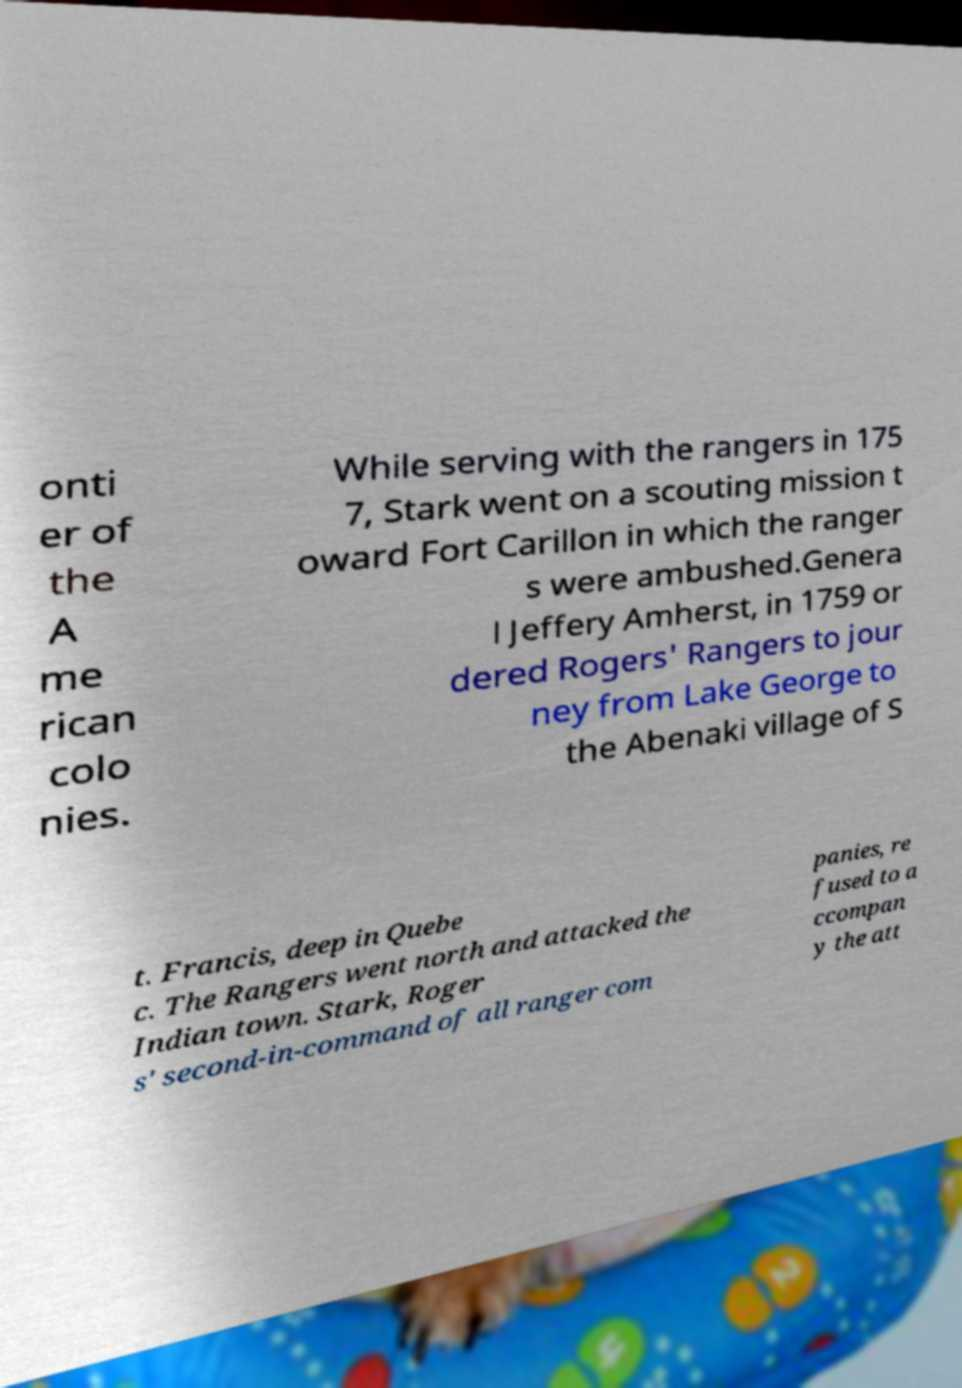Please identify and transcribe the text found in this image. onti er of the A me rican colo nies. While serving with the rangers in 175 7, Stark went on a scouting mission t oward Fort Carillon in which the ranger s were ambushed.Genera l Jeffery Amherst, in 1759 or dered Rogers' Rangers to jour ney from Lake George to the Abenaki village of S t. Francis, deep in Quebe c. The Rangers went north and attacked the Indian town. Stark, Roger s' second-in-command of all ranger com panies, re fused to a ccompan y the att 